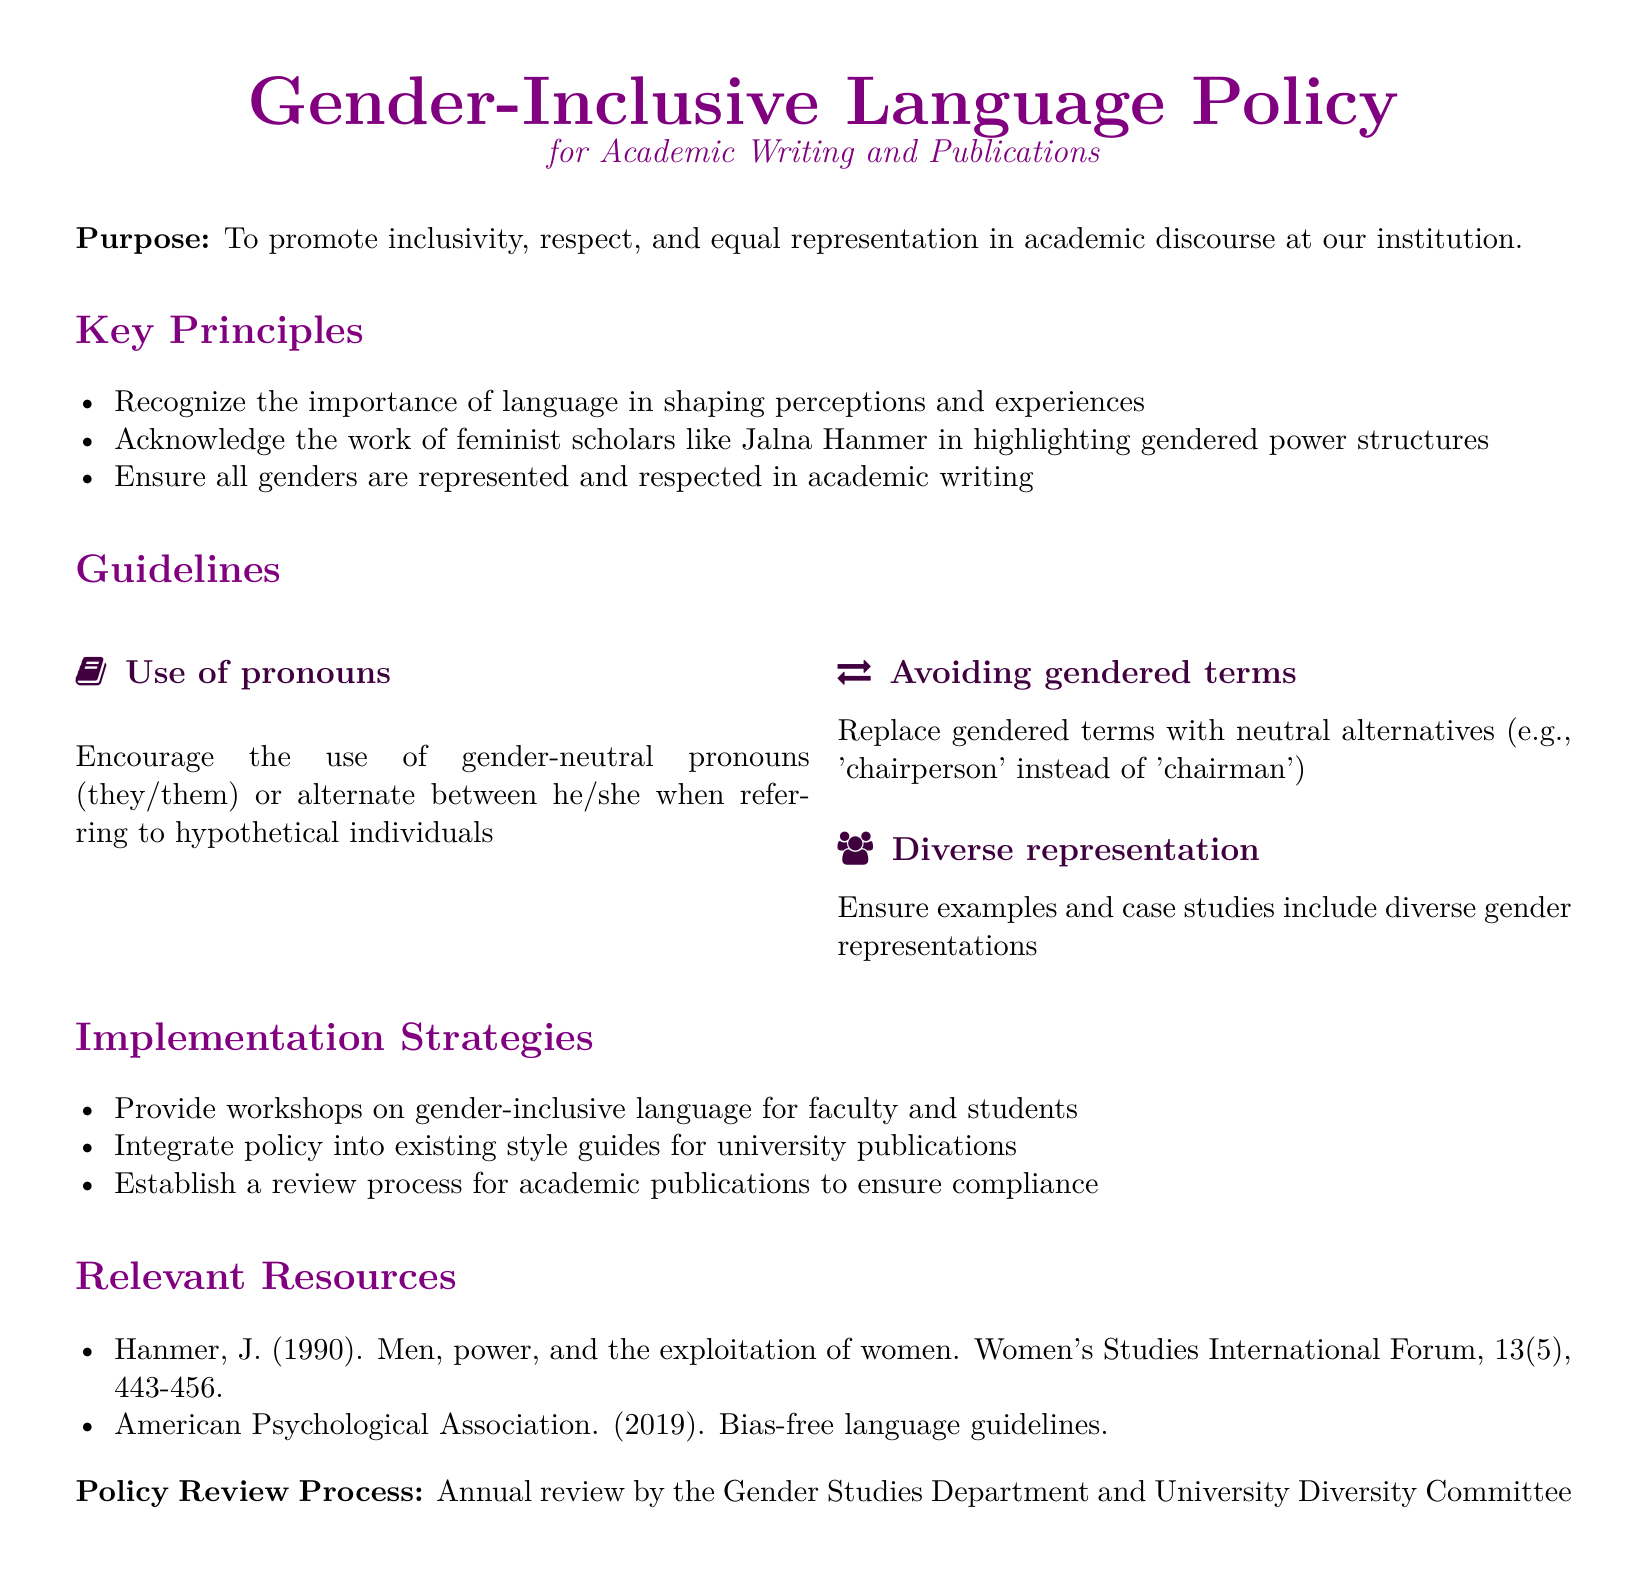What is the purpose of the policy? The purpose is stated as promoting inclusivity, respect, and equal representation in academic discourse at the institution.
Answer: To promote inclusivity, respect, and equal representation in academic discourse at our institution Who is recognized in the policy for highlighting gendered power structures? The policy acknowledges the work of feminist scholars, specifically mentioning Jalna Hanmer.
Answer: Jalna Hanmer What is suggested for the use of pronouns? The policy encourages the use of gender-neutral pronouns or alternation between he and she for hypothetical individuals.
Answer: Use gender-neutral pronouns or alternate between he/she What is an example of avoiding gendered terms? An example provided is replacing 'chairman' with 'chairperson'.
Answer: 'chairperson' How often is the policy supposed to be reviewed? The document specifies that the policy will undergo an annual review process.
Answer: Annual review What type of workshops does the policy propose? The policy suggests providing workshops on gender-inclusive language.
Answer: Workshops on gender-inclusive language What department is responsible for the policy review? The Gender Studies Department and the University Diversity Committee are responsible for the annual review process.
Answer: Gender Studies Department and University Diversity Committee What guideline involves diverse representation? The guideline ensures examples and case studies include diverse gender representations.
Answer: Ensure diverse gender representations 